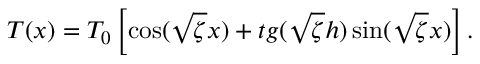<formula> <loc_0><loc_0><loc_500><loc_500>T ( x ) = { T _ { 0 } } \left [ { \cos ( \sqrt { \zeta } x ) + t g ( \sqrt { \zeta } h ) \sin ( \sqrt { \zeta } x ) } \right ] .</formula> 